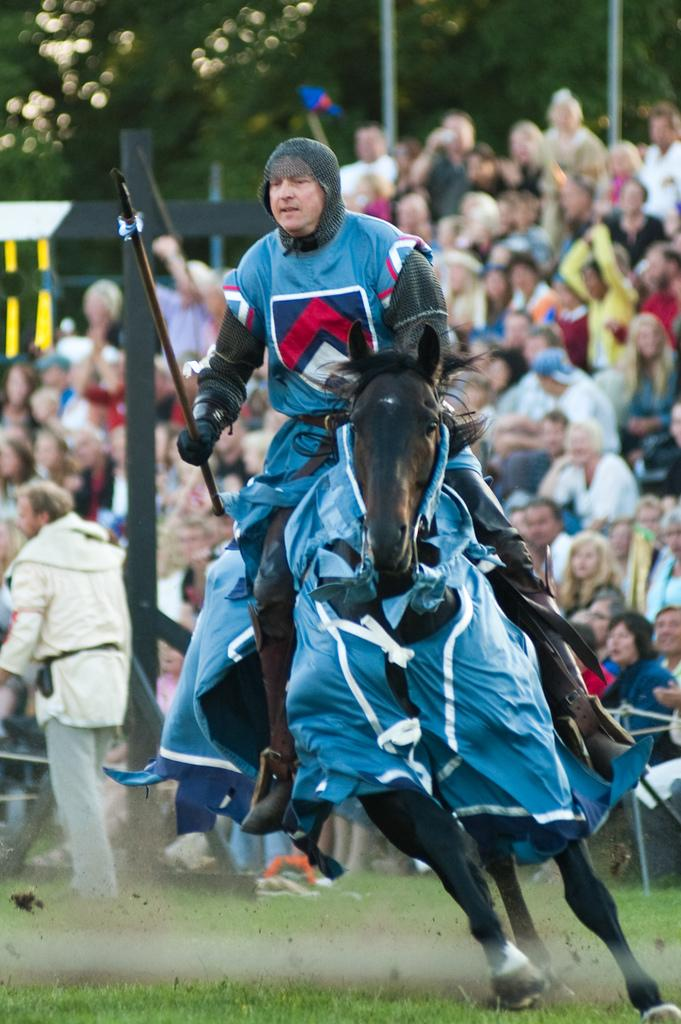What is the main subject of the image? There is a man riding a horse in the image. What can be seen in the background of the image? There are people sitting in the background of the image. What type of vegetation is visible in the image? There is a tree visible in the image. What type of bird is marking its territory in the image? There is no bird present in the image, and therefore no bird can be marking its territory. 